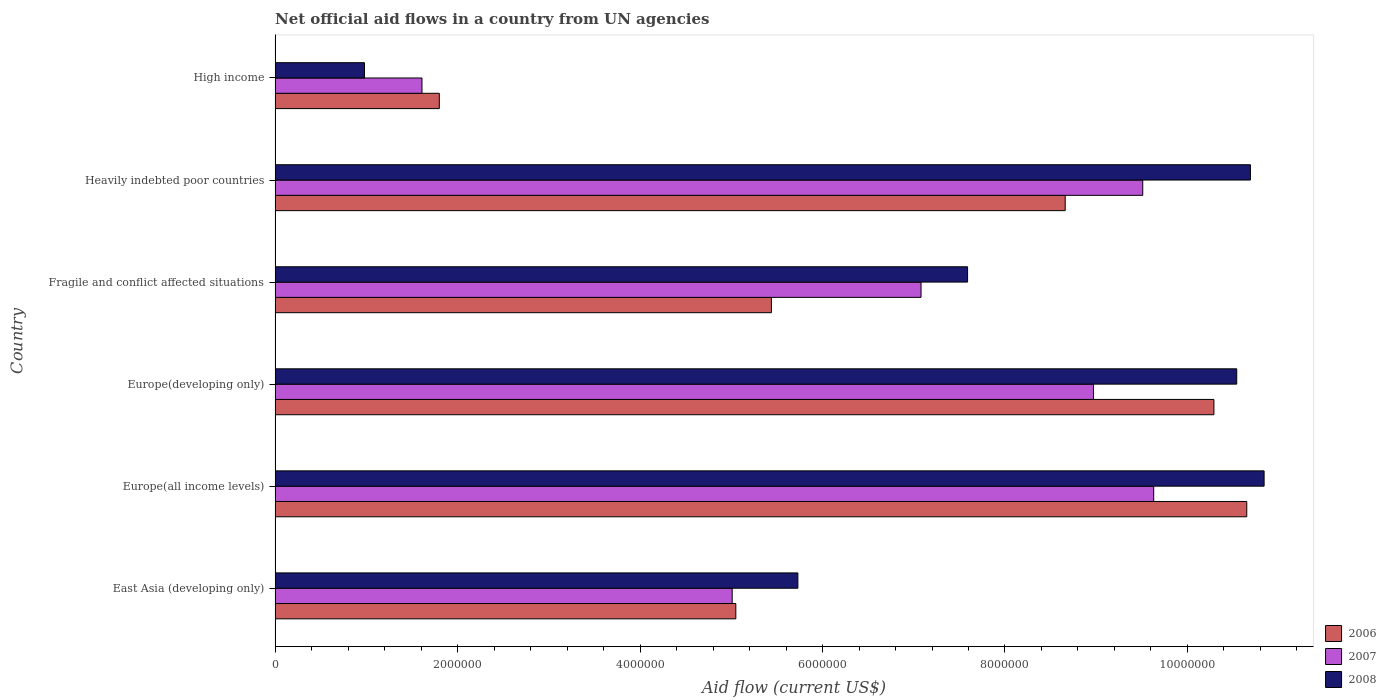How many groups of bars are there?
Offer a very short reply. 6. What is the label of the 1st group of bars from the top?
Offer a terse response. High income. In how many cases, is the number of bars for a given country not equal to the number of legend labels?
Keep it short and to the point. 0. What is the net official aid flow in 2008 in Europe(developing only)?
Offer a very short reply. 1.05e+07. Across all countries, what is the maximum net official aid flow in 2008?
Your answer should be very brief. 1.08e+07. Across all countries, what is the minimum net official aid flow in 2007?
Give a very brief answer. 1.61e+06. In which country was the net official aid flow in 2007 maximum?
Offer a very short reply. Europe(all income levels). In which country was the net official aid flow in 2008 minimum?
Offer a terse response. High income. What is the total net official aid flow in 2007 in the graph?
Offer a terse response. 4.18e+07. What is the difference between the net official aid flow in 2008 in East Asia (developing only) and that in Europe(developing only)?
Your answer should be compact. -4.81e+06. What is the difference between the net official aid flow in 2006 in High income and the net official aid flow in 2007 in Europe(all income levels)?
Keep it short and to the point. -7.83e+06. What is the average net official aid flow in 2008 per country?
Give a very brief answer. 7.73e+06. What is the difference between the net official aid flow in 2007 and net official aid flow in 2006 in Heavily indebted poor countries?
Provide a short and direct response. 8.50e+05. What is the ratio of the net official aid flow in 2008 in Europe(developing only) to that in Heavily indebted poor countries?
Provide a short and direct response. 0.99. Is the net official aid flow in 2006 in Fragile and conflict affected situations less than that in High income?
Your response must be concise. No. What is the difference between the highest and the lowest net official aid flow in 2006?
Provide a short and direct response. 8.85e+06. What does the 1st bar from the bottom in Europe(all income levels) represents?
Make the answer very short. 2006. How many countries are there in the graph?
Give a very brief answer. 6. What is the difference between two consecutive major ticks on the X-axis?
Your answer should be very brief. 2.00e+06. Are the values on the major ticks of X-axis written in scientific E-notation?
Give a very brief answer. No. Does the graph contain grids?
Give a very brief answer. No. How many legend labels are there?
Offer a very short reply. 3. What is the title of the graph?
Offer a very short reply. Net official aid flows in a country from UN agencies. What is the Aid flow (current US$) in 2006 in East Asia (developing only)?
Provide a short and direct response. 5.05e+06. What is the Aid flow (current US$) in 2007 in East Asia (developing only)?
Offer a very short reply. 5.01e+06. What is the Aid flow (current US$) of 2008 in East Asia (developing only)?
Give a very brief answer. 5.73e+06. What is the Aid flow (current US$) of 2006 in Europe(all income levels)?
Offer a terse response. 1.06e+07. What is the Aid flow (current US$) in 2007 in Europe(all income levels)?
Provide a short and direct response. 9.63e+06. What is the Aid flow (current US$) of 2008 in Europe(all income levels)?
Keep it short and to the point. 1.08e+07. What is the Aid flow (current US$) in 2006 in Europe(developing only)?
Keep it short and to the point. 1.03e+07. What is the Aid flow (current US$) in 2007 in Europe(developing only)?
Your answer should be very brief. 8.97e+06. What is the Aid flow (current US$) of 2008 in Europe(developing only)?
Provide a succinct answer. 1.05e+07. What is the Aid flow (current US$) of 2006 in Fragile and conflict affected situations?
Your response must be concise. 5.44e+06. What is the Aid flow (current US$) in 2007 in Fragile and conflict affected situations?
Your response must be concise. 7.08e+06. What is the Aid flow (current US$) of 2008 in Fragile and conflict affected situations?
Your response must be concise. 7.59e+06. What is the Aid flow (current US$) in 2006 in Heavily indebted poor countries?
Your answer should be compact. 8.66e+06. What is the Aid flow (current US$) of 2007 in Heavily indebted poor countries?
Your answer should be very brief. 9.51e+06. What is the Aid flow (current US$) in 2008 in Heavily indebted poor countries?
Keep it short and to the point. 1.07e+07. What is the Aid flow (current US$) of 2006 in High income?
Your answer should be very brief. 1.80e+06. What is the Aid flow (current US$) of 2007 in High income?
Offer a terse response. 1.61e+06. What is the Aid flow (current US$) in 2008 in High income?
Your answer should be very brief. 9.80e+05. Across all countries, what is the maximum Aid flow (current US$) in 2006?
Provide a succinct answer. 1.06e+07. Across all countries, what is the maximum Aid flow (current US$) of 2007?
Give a very brief answer. 9.63e+06. Across all countries, what is the maximum Aid flow (current US$) of 2008?
Provide a short and direct response. 1.08e+07. Across all countries, what is the minimum Aid flow (current US$) in 2006?
Your answer should be compact. 1.80e+06. Across all countries, what is the minimum Aid flow (current US$) of 2007?
Your answer should be very brief. 1.61e+06. Across all countries, what is the minimum Aid flow (current US$) of 2008?
Your response must be concise. 9.80e+05. What is the total Aid flow (current US$) in 2006 in the graph?
Provide a succinct answer. 4.19e+07. What is the total Aid flow (current US$) in 2007 in the graph?
Provide a succinct answer. 4.18e+07. What is the total Aid flow (current US$) in 2008 in the graph?
Provide a short and direct response. 4.64e+07. What is the difference between the Aid flow (current US$) of 2006 in East Asia (developing only) and that in Europe(all income levels)?
Keep it short and to the point. -5.60e+06. What is the difference between the Aid flow (current US$) of 2007 in East Asia (developing only) and that in Europe(all income levels)?
Make the answer very short. -4.62e+06. What is the difference between the Aid flow (current US$) of 2008 in East Asia (developing only) and that in Europe(all income levels)?
Provide a succinct answer. -5.11e+06. What is the difference between the Aid flow (current US$) in 2006 in East Asia (developing only) and that in Europe(developing only)?
Provide a short and direct response. -5.24e+06. What is the difference between the Aid flow (current US$) in 2007 in East Asia (developing only) and that in Europe(developing only)?
Keep it short and to the point. -3.96e+06. What is the difference between the Aid flow (current US$) in 2008 in East Asia (developing only) and that in Europe(developing only)?
Give a very brief answer. -4.81e+06. What is the difference between the Aid flow (current US$) in 2006 in East Asia (developing only) and that in Fragile and conflict affected situations?
Keep it short and to the point. -3.90e+05. What is the difference between the Aid flow (current US$) of 2007 in East Asia (developing only) and that in Fragile and conflict affected situations?
Keep it short and to the point. -2.07e+06. What is the difference between the Aid flow (current US$) in 2008 in East Asia (developing only) and that in Fragile and conflict affected situations?
Keep it short and to the point. -1.86e+06. What is the difference between the Aid flow (current US$) in 2006 in East Asia (developing only) and that in Heavily indebted poor countries?
Provide a succinct answer. -3.61e+06. What is the difference between the Aid flow (current US$) of 2007 in East Asia (developing only) and that in Heavily indebted poor countries?
Your answer should be compact. -4.50e+06. What is the difference between the Aid flow (current US$) in 2008 in East Asia (developing only) and that in Heavily indebted poor countries?
Offer a very short reply. -4.96e+06. What is the difference between the Aid flow (current US$) in 2006 in East Asia (developing only) and that in High income?
Give a very brief answer. 3.25e+06. What is the difference between the Aid flow (current US$) in 2007 in East Asia (developing only) and that in High income?
Give a very brief answer. 3.40e+06. What is the difference between the Aid flow (current US$) in 2008 in East Asia (developing only) and that in High income?
Make the answer very short. 4.75e+06. What is the difference between the Aid flow (current US$) of 2006 in Europe(all income levels) and that in Europe(developing only)?
Your answer should be compact. 3.60e+05. What is the difference between the Aid flow (current US$) in 2008 in Europe(all income levels) and that in Europe(developing only)?
Keep it short and to the point. 3.00e+05. What is the difference between the Aid flow (current US$) in 2006 in Europe(all income levels) and that in Fragile and conflict affected situations?
Provide a short and direct response. 5.21e+06. What is the difference between the Aid flow (current US$) in 2007 in Europe(all income levels) and that in Fragile and conflict affected situations?
Your answer should be compact. 2.55e+06. What is the difference between the Aid flow (current US$) of 2008 in Europe(all income levels) and that in Fragile and conflict affected situations?
Your answer should be very brief. 3.25e+06. What is the difference between the Aid flow (current US$) of 2006 in Europe(all income levels) and that in Heavily indebted poor countries?
Ensure brevity in your answer.  1.99e+06. What is the difference between the Aid flow (current US$) of 2007 in Europe(all income levels) and that in Heavily indebted poor countries?
Make the answer very short. 1.20e+05. What is the difference between the Aid flow (current US$) of 2006 in Europe(all income levels) and that in High income?
Give a very brief answer. 8.85e+06. What is the difference between the Aid flow (current US$) in 2007 in Europe(all income levels) and that in High income?
Your answer should be very brief. 8.02e+06. What is the difference between the Aid flow (current US$) of 2008 in Europe(all income levels) and that in High income?
Your answer should be compact. 9.86e+06. What is the difference between the Aid flow (current US$) of 2006 in Europe(developing only) and that in Fragile and conflict affected situations?
Your answer should be compact. 4.85e+06. What is the difference between the Aid flow (current US$) of 2007 in Europe(developing only) and that in Fragile and conflict affected situations?
Your answer should be very brief. 1.89e+06. What is the difference between the Aid flow (current US$) in 2008 in Europe(developing only) and that in Fragile and conflict affected situations?
Ensure brevity in your answer.  2.95e+06. What is the difference between the Aid flow (current US$) in 2006 in Europe(developing only) and that in Heavily indebted poor countries?
Your answer should be very brief. 1.63e+06. What is the difference between the Aid flow (current US$) in 2007 in Europe(developing only) and that in Heavily indebted poor countries?
Offer a terse response. -5.40e+05. What is the difference between the Aid flow (current US$) of 2008 in Europe(developing only) and that in Heavily indebted poor countries?
Keep it short and to the point. -1.50e+05. What is the difference between the Aid flow (current US$) of 2006 in Europe(developing only) and that in High income?
Provide a short and direct response. 8.49e+06. What is the difference between the Aid flow (current US$) in 2007 in Europe(developing only) and that in High income?
Provide a succinct answer. 7.36e+06. What is the difference between the Aid flow (current US$) in 2008 in Europe(developing only) and that in High income?
Give a very brief answer. 9.56e+06. What is the difference between the Aid flow (current US$) of 2006 in Fragile and conflict affected situations and that in Heavily indebted poor countries?
Provide a short and direct response. -3.22e+06. What is the difference between the Aid flow (current US$) in 2007 in Fragile and conflict affected situations and that in Heavily indebted poor countries?
Ensure brevity in your answer.  -2.43e+06. What is the difference between the Aid flow (current US$) in 2008 in Fragile and conflict affected situations and that in Heavily indebted poor countries?
Ensure brevity in your answer.  -3.10e+06. What is the difference between the Aid flow (current US$) of 2006 in Fragile and conflict affected situations and that in High income?
Offer a terse response. 3.64e+06. What is the difference between the Aid flow (current US$) in 2007 in Fragile and conflict affected situations and that in High income?
Provide a succinct answer. 5.47e+06. What is the difference between the Aid flow (current US$) of 2008 in Fragile and conflict affected situations and that in High income?
Your response must be concise. 6.61e+06. What is the difference between the Aid flow (current US$) in 2006 in Heavily indebted poor countries and that in High income?
Make the answer very short. 6.86e+06. What is the difference between the Aid flow (current US$) in 2007 in Heavily indebted poor countries and that in High income?
Give a very brief answer. 7.90e+06. What is the difference between the Aid flow (current US$) of 2008 in Heavily indebted poor countries and that in High income?
Give a very brief answer. 9.71e+06. What is the difference between the Aid flow (current US$) in 2006 in East Asia (developing only) and the Aid flow (current US$) in 2007 in Europe(all income levels)?
Offer a terse response. -4.58e+06. What is the difference between the Aid flow (current US$) of 2006 in East Asia (developing only) and the Aid flow (current US$) of 2008 in Europe(all income levels)?
Give a very brief answer. -5.79e+06. What is the difference between the Aid flow (current US$) in 2007 in East Asia (developing only) and the Aid flow (current US$) in 2008 in Europe(all income levels)?
Provide a short and direct response. -5.83e+06. What is the difference between the Aid flow (current US$) of 2006 in East Asia (developing only) and the Aid flow (current US$) of 2007 in Europe(developing only)?
Your answer should be compact. -3.92e+06. What is the difference between the Aid flow (current US$) in 2006 in East Asia (developing only) and the Aid flow (current US$) in 2008 in Europe(developing only)?
Keep it short and to the point. -5.49e+06. What is the difference between the Aid flow (current US$) in 2007 in East Asia (developing only) and the Aid flow (current US$) in 2008 in Europe(developing only)?
Offer a terse response. -5.53e+06. What is the difference between the Aid flow (current US$) of 2006 in East Asia (developing only) and the Aid flow (current US$) of 2007 in Fragile and conflict affected situations?
Offer a terse response. -2.03e+06. What is the difference between the Aid flow (current US$) in 2006 in East Asia (developing only) and the Aid flow (current US$) in 2008 in Fragile and conflict affected situations?
Your answer should be very brief. -2.54e+06. What is the difference between the Aid flow (current US$) of 2007 in East Asia (developing only) and the Aid flow (current US$) of 2008 in Fragile and conflict affected situations?
Offer a terse response. -2.58e+06. What is the difference between the Aid flow (current US$) in 2006 in East Asia (developing only) and the Aid flow (current US$) in 2007 in Heavily indebted poor countries?
Give a very brief answer. -4.46e+06. What is the difference between the Aid flow (current US$) in 2006 in East Asia (developing only) and the Aid flow (current US$) in 2008 in Heavily indebted poor countries?
Make the answer very short. -5.64e+06. What is the difference between the Aid flow (current US$) of 2007 in East Asia (developing only) and the Aid flow (current US$) of 2008 in Heavily indebted poor countries?
Offer a terse response. -5.68e+06. What is the difference between the Aid flow (current US$) of 2006 in East Asia (developing only) and the Aid flow (current US$) of 2007 in High income?
Keep it short and to the point. 3.44e+06. What is the difference between the Aid flow (current US$) in 2006 in East Asia (developing only) and the Aid flow (current US$) in 2008 in High income?
Offer a very short reply. 4.07e+06. What is the difference between the Aid flow (current US$) of 2007 in East Asia (developing only) and the Aid flow (current US$) of 2008 in High income?
Provide a succinct answer. 4.03e+06. What is the difference between the Aid flow (current US$) of 2006 in Europe(all income levels) and the Aid flow (current US$) of 2007 in Europe(developing only)?
Your response must be concise. 1.68e+06. What is the difference between the Aid flow (current US$) of 2007 in Europe(all income levels) and the Aid flow (current US$) of 2008 in Europe(developing only)?
Offer a terse response. -9.10e+05. What is the difference between the Aid flow (current US$) in 2006 in Europe(all income levels) and the Aid flow (current US$) in 2007 in Fragile and conflict affected situations?
Ensure brevity in your answer.  3.57e+06. What is the difference between the Aid flow (current US$) in 2006 in Europe(all income levels) and the Aid flow (current US$) in 2008 in Fragile and conflict affected situations?
Make the answer very short. 3.06e+06. What is the difference between the Aid flow (current US$) of 2007 in Europe(all income levels) and the Aid flow (current US$) of 2008 in Fragile and conflict affected situations?
Provide a short and direct response. 2.04e+06. What is the difference between the Aid flow (current US$) of 2006 in Europe(all income levels) and the Aid flow (current US$) of 2007 in Heavily indebted poor countries?
Your response must be concise. 1.14e+06. What is the difference between the Aid flow (current US$) of 2006 in Europe(all income levels) and the Aid flow (current US$) of 2008 in Heavily indebted poor countries?
Offer a terse response. -4.00e+04. What is the difference between the Aid flow (current US$) in 2007 in Europe(all income levels) and the Aid flow (current US$) in 2008 in Heavily indebted poor countries?
Your answer should be compact. -1.06e+06. What is the difference between the Aid flow (current US$) in 2006 in Europe(all income levels) and the Aid flow (current US$) in 2007 in High income?
Make the answer very short. 9.04e+06. What is the difference between the Aid flow (current US$) of 2006 in Europe(all income levels) and the Aid flow (current US$) of 2008 in High income?
Your response must be concise. 9.67e+06. What is the difference between the Aid flow (current US$) in 2007 in Europe(all income levels) and the Aid flow (current US$) in 2008 in High income?
Your answer should be compact. 8.65e+06. What is the difference between the Aid flow (current US$) in 2006 in Europe(developing only) and the Aid flow (current US$) in 2007 in Fragile and conflict affected situations?
Provide a short and direct response. 3.21e+06. What is the difference between the Aid flow (current US$) of 2006 in Europe(developing only) and the Aid flow (current US$) of 2008 in Fragile and conflict affected situations?
Your response must be concise. 2.70e+06. What is the difference between the Aid flow (current US$) in 2007 in Europe(developing only) and the Aid flow (current US$) in 2008 in Fragile and conflict affected situations?
Your answer should be very brief. 1.38e+06. What is the difference between the Aid flow (current US$) in 2006 in Europe(developing only) and the Aid flow (current US$) in 2007 in Heavily indebted poor countries?
Give a very brief answer. 7.80e+05. What is the difference between the Aid flow (current US$) of 2006 in Europe(developing only) and the Aid flow (current US$) of 2008 in Heavily indebted poor countries?
Give a very brief answer. -4.00e+05. What is the difference between the Aid flow (current US$) of 2007 in Europe(developing only) and the Aid flow (current US$) of 2008 in Heavily indebted poor countries?
Make the answer very short. -1.72e+06. What is the difference between the Aid flow (current US$) in 2006 in Europe(developing only) and the Aid flow (current US$) in 2007 in High income?
Offer a very short reply. 8.68e+06. What is the difference between the Aid flow (current US$) of 2006 in Europe(developing only) and the Aid flow (current US$) of 2008 in High income?
Provide a succinct answer. 9.31e+06. What is the difference between the Aid flow (current US$) of 2007 in Europe(developing only) and the Aid flow (current US$) of 2008 in High income?
Your answer should be compact. 7.99e+06. What is the difference between the Aid flow (current US$) in 2006 in Fragile and conflict affected situations and the Aid flow (current US$) in 2007 in Heavily indebted poor countries?
Keep it short and to the point. -4.07e+06. What is the difference between the Aid flow (current US$) in 2006 in Fragile and conflict affected situations and the Aid flow (current US$) in 2008 in Heavily indebted poor countries?
Provide a short and direct response. -5.25e+06. What is the difference between the Aid flow (current US$) in 2007 in Fragile and conflict affected situations and the Aid flow (current US$) in 2008 in Heavily indebted poor countries?
Your answer should be very brief. -3.61e+06. What is the difference between the Aid flow (current US$) of 2006 in Fragile and conflict affected situations and the Aid flow (current US$) of 2007 in High income?
Your answer should be very brief. 3.83e+06. What is the difference between the Aid flow (current US$) in 2006 in Fragile and conflict affected situations and the Aid flow (current US$) in 2008 in High income?
Ensure brevity in your answer.  4.46e+06. What is the difference between the Aid flow (current US$) of 2007 in Fragile and conflict affected situations and the Aid flow (current US$) of 2008 in High income?
Make the answer very short. 6.10e+06. What is the difference between the Aid flow (current US$) in 2006 in Heavily indebted poor countries and the Aid flow (current US$) in 2007 in High income?
Offer a very short reply. 7.05e+06. What is the difference between the Aid flow (current US$) of 2006 in Heavily indebted poor countries and the Aid flow (current US$) of 2008 in High income?
Your response must be concise. 7.68e+06. What is the difference between the Aid flow (current US$) of 2007 in Heavily indebted poor countries and the Aid flow (current US$) of 2008 in High income?
Your answer should be compact. 8.53e+06. What is the average Aid flow (current US$) in 2006 per country?
Make the answer very short. 6.98e+06. What is the average Aid flow (current US$) in 2007 per country?
Offer a very short reply. 6.97e+06. What is the average Aid flow (current US$) in 2008 per country?
Your answer should be compact. 7.73e+06. What is the difference between the Aid flow (current US$) in 2006 and Aid flow (current US$) in 2008 in East Asia (developing only)?
Your answer should be compact. -6.80e+05. What is the difference between the Aid flow (current US$) of 2007 and Aid flow (current US$) of 2008 in East Asia (developing only)?
Offer a terse response. -7.20e+05. What is the difference between the Aid flow (current US$) of 2006 and Aid flow (current US$) of 2007 in Europe(all income levels)?
Give a very brief answer. 1.02e+06. What is the difference between the Aid flow (current US$) of 2006 and Aid flow (current US$) of 2008 in Europe(all income levels)?
Make the answer very short. -1.90e+05. What is the difference between the Aid flow (current US$) in 2007 and Aid flow (current US$) in 2008 in Europe(all income levels)?
Your response must be concise. -1.21e+06. What is the difference between the Aid flow (current US$) of 2006 and Aid flow (current US$) of 2007 in Europe(developing only)?
Offer a terse response. 1.32e+06. What is the difference between the Aid flow (current US$) in 2007 and Aid flow (current US$) in 2008 in Europe(developing only)?
Give a very brief answer. -1.57e+06. What is the difference between the Aid flow (current US$) of 2006 and Aid flow (current US$) of 2007 in Fragile and conflict affected situations?
Your response must be concise. -1.64e+06. What is the difference between the Aid flow (current US$) of 2006 and Aid flow (current US$) of 2008 in Fragile and conflict affected situations?
Offer a very short reply. -2.15e+06. What is the difference between the Aid flow (current US$) in 2007 and Aid flow (current US$) in 2008 in Fragile and conflict affected situations?
Provide a succinct answer. -5.10e+05. What is the difference between the Aid flow (current US$) of 2006 and Aid flow (current US$) of 2007 in Heavily indebted poor countries?
Offer a terse response. -8.50e+05. What is the difference between the Aid flow (current US$) in 2006 and Aid flow (current US$) in 2008 in Heavily indebted poor countries?
Ensure brevity in your answer.  -2.03e+06. What is the difference between the Aid flow (current US$) of 2007 and Aid flow (current US$) of 2008 in Heavily indebted poor countries?
Your response must be concise. -1.18e+06. What is the difference between the Aid flow (current US$) of 2006 and Aid flow (current US$) of 2007 in High income?
Keep it short and to the point. 1.90e+05. What is the difference between the Aid flow (current US$) in 2006 and Aid flow (current US$) in 2008 in High income?
Ensure brevity in your answer.  8.20e+05. What is the difference between the Aid flow (current US$) in 2007 and Aid flow (current US$) in 2008 in High income?
Provide a succinct answer. 6.30e+05. What is the ratio of the Aid flow (current US$) in 2006 in East Asia (developing only) to that in Europe(all income levels)?
Ensure brevity in your answer.  0.47. What is the ratio of the Aid flow (current US$) in 2007 in East Asia (developing only) to that in Europe(all income levels)?
Provide a short and direct response. 0.52. What is the ratio of the Aid flow (current US$) in 2008 in East Asia (developing only) to that in Europe(all income levels)?
Offer a terse response. 0.53. What is the ratio of the Aid flow (current US$) in 2006 in East Asia (developing only) to that in Europe(developing only)?
Keep it short and to the point. 0.49. What is the ratio of the Aid flow (current US$) of 2007 in East Asia (developing only) to that in Europe(developing only)?
Ensure brevity in your answer.  0.56. What is the ratio of the Aid flow (current US$) of 2008 in East Asia (developing only) to that in Europe(developing only)?
Your answer should be very brief. 0.54. What is the ratio of the Aid flow (current US$) in 2006 in East Asia (developing only) to that in Fragile and conflict affected situations?
Offer a very short reply. 0.93. What is the ratio of the Aid flow (current US$) of 2007 in East Asia (developing only) to that in Fragile and conflict affected situations?
Give a very brief answer. 0.71. What is the ratio of the Aid flow (current US$) in 2008 in East Asia (developing only) to that in Fragile and conflict affected situations?
Ensure brevity in your answer.  0.75. What is the ratio of the Aid flow (current US$) of 2006 in East Asia (developing only) to that in Heavily indebted poor countries?
Give a very brief answer. 0.58. What is the ratio of the Aid flow (current US$) of 2007 in East Asia (developing only) to that in Heavily indebted poor countries?
Your answer should be compact. 0.53. What is the ratio of the Aid flow (current US$) in 2008 in East Asia (developing only) to that in Heavily indebted poor countries?
Provide a short and direct response. 0.54. What is the ratio of the Aid flow (current US$) in 2006 in East Asia (developing only) to that in High income?
Provide a short and direct response. 2.81. What is the ratio of the Aid flow (current US$) of 2007 in East Asia (developing only) to that in High income?
Offer a very short reply. 3.11. What is the ratio of the Aid flow (current US$) in 2008 in East Asia (developing only) to that in High income?
Give a very brief answer. 5.85. What is the ratio of the Aid flow (current US$) of 2006 in Europe(all income levels) to that in Europe(developing only)?
Your response must be concise. 1.03. What is the ratio of the Aid flow (current US$) in 2007 in Europe(all income levels) to that in Europe(developing only)?
Provide a succinct answer. 1.07. What is the ratio of the Aid flow (current US$) of 2008 in Europe(all income levels) to that in Europe(developing only)?
Provide a succinct answer. 1.03. What is the ratio of the Aid flow (current US$) of 2006 in Europe(all income levels) to that in Fragile and conflict affected situations?
Offer a terse response. 1.96. What is the ratio of the Aid flow (current US$) in 2007 in Europe(all income levels) to that in Fragile and conflict affected situations?
Keep it short and to the point. 1.36. What is the ratio of the Aid flow (current US$) of 2008 in Europe(all income levels) to that in Fragile and conflict affected situations?
Provide a short and direct response. 1.43. What is the ratio of the Aid flow (current US$) of 2006 in Europe(all income levels) to that in Heavily indebted poor countries?
Your response must be concise. 1.23. What is the ratio of the Aid flow (current US$) of 2007 in Europe(all income levels) to that in Heavily indebted poor countries?
Offer a terse response. 1.01. What is the ratio of the Aid flow (current US$) in 2008 in Europe(all income levels) to that in Heavily indebted poor countries?
Your answer should be very brief. 1.01. What is the ratio of the Aid flow (current US$) in 2006 in Europe(all income levels) to that in High income?
Your answer should be compact. 5.92. What is the ratio of the Aid flow (current US$) of 2007 in Europe(all income levels) to that in High income?
Offer a terse response. 5.98. What is the ratio of the Aid flow (current US$) of 2008 in Europe(all income levels) to that in High income?
Keep it short and to the point. 11.06. What is the ratio of the Aid flow (current US$) of 2006 in Europe(developing only) to that in Fragile and conflict affected situations?
Offer a very short reply. 1.89. What is the ratio of the Aid flow (current US$) in 2007 in Europe(developing only) to that in Fragile and conflict affected situations?
Give a very brief answer. 1.27. What is the ratio of the Aid flow (current US$) of 2008 in Europe(developing only) to that in Fragile and conflict affected situations?
Keep it short and to the point. 1.39. What is the ratio of the Aid flow (current US$) in 2006 in Europe(developing only) to that in Heavily indebted poor countries?
Your response must be concise. 1.19. What is the ratio of the Aid flow (current US$) of 2007 in Europe(developing only) to that in Heavily indebted poor countries?
Your answer should be very brief. 0.94. What is the ratio of the Aid flow (current US$) of 2008 in Europe(developing only) to that in Heavily indebted poor countries?
Make the answer very short. 0.99. What is the ratio of the Aid flow (current US$) in 2006 in Europe(developing only) to that in High income?
Your response must be concise. 5.72. What is the ratio of the Aid flow (current US$) of 2007 in Europe(developing only) to that in High income?
Give a very brief answer. 5.57. What is the ratio of the Aid flow (current US$) of 2008 in Europe(developing only) to that in High income?
Offer a very short reply. 10.76. What is the ratio of the Aid flow (current US$) in 2006 in Fragile and conflict affected situations to that in Heavily indebted poor countries?
Offer a terse response. 0.63. What is the ratio of the Aid flow (current US$) of 2007 in Fragile and conflict affected situations to that in Heavily indebted poor countries?
Give a very brief answer. 0.74. What is the ratio of the Aid flow (current US$) of 2008 in Fragile and conflict affected situations to that in Heavily indebted poor countries?
Provide a short and direct response. 0.71. What is the ratio of the Aid flow (current US$) in 2006 in Fragile and conflict affected situations to that in High income?
Your answer should be compact. 3.02. What is the ratio of the Aid flow (current US$) in 2007 in Fragile and conflict affected situations to that in High income?
Provide a short and direct response. 4.4. What is the ratio of the Aid flow (current US$) of 2008 in Fragile and conflict affected situations to that in High income?
Your answer should be compact. 7.74. What is the ratio of the Aid flow (current US$) in 2006 in Heavily indebted poor countries to that in High income?
Make the answer very short. 4.81. What is the ratio of the Aid flow (current US$) in 2007 in Heavily indebted poor countries to that in High income?
Provide a succinct answer. 5.91. What is the ratio of the Aid flow (current US$) of 2008 in Heavily indebted poor countries to that in High income?
Offer a terse response. 10.91. What is the difference between the highest and the second highest Aid flow (current US$) of 2007?
Keep it short and to the point. 1.20e+05. What is the difference between the highest and the lowest Aid flow (current US$) in 2006?
Offer a very short reply. 8.85e+06. What is the difference between the highest and the lowest Aid flow (current US$) of 2007?
Keep it short and to the point. 8.02e+06. What is the difference between the highest and the lowest Aid flow (current US$) of 2008?
Provide a succinct answer. 9.86e+06. 